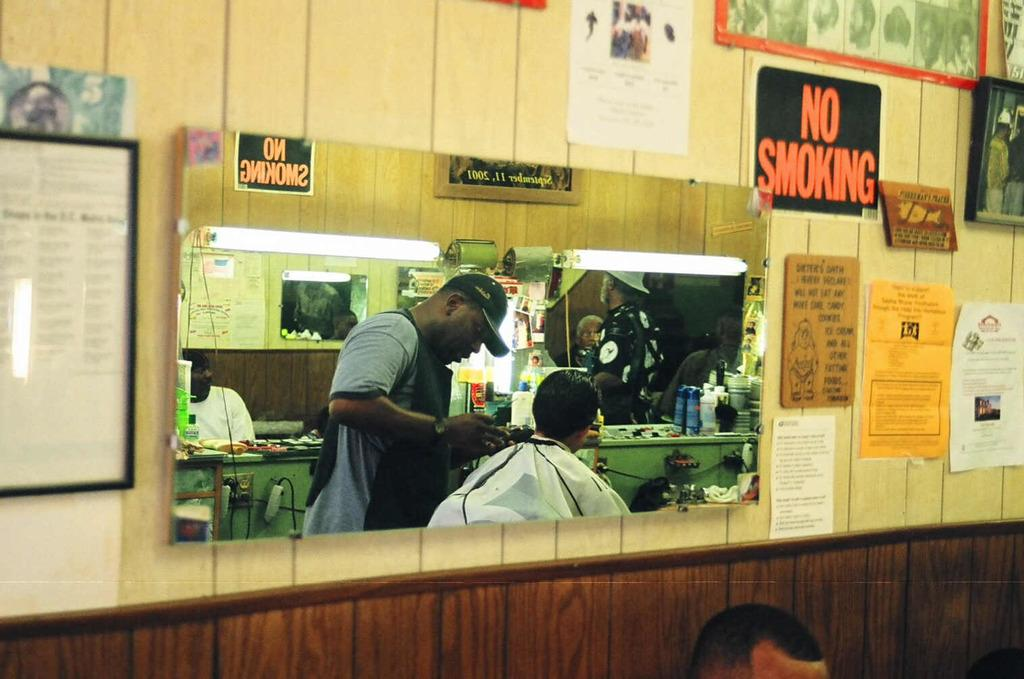What is present in the image? There is a person in the image. What can be seen on the wall in the image? There is a mirror, photo frames, and posters on the wall. What type of jelly is visible on the person's thumb in the image? There is no jelly or thumb present in the image. 